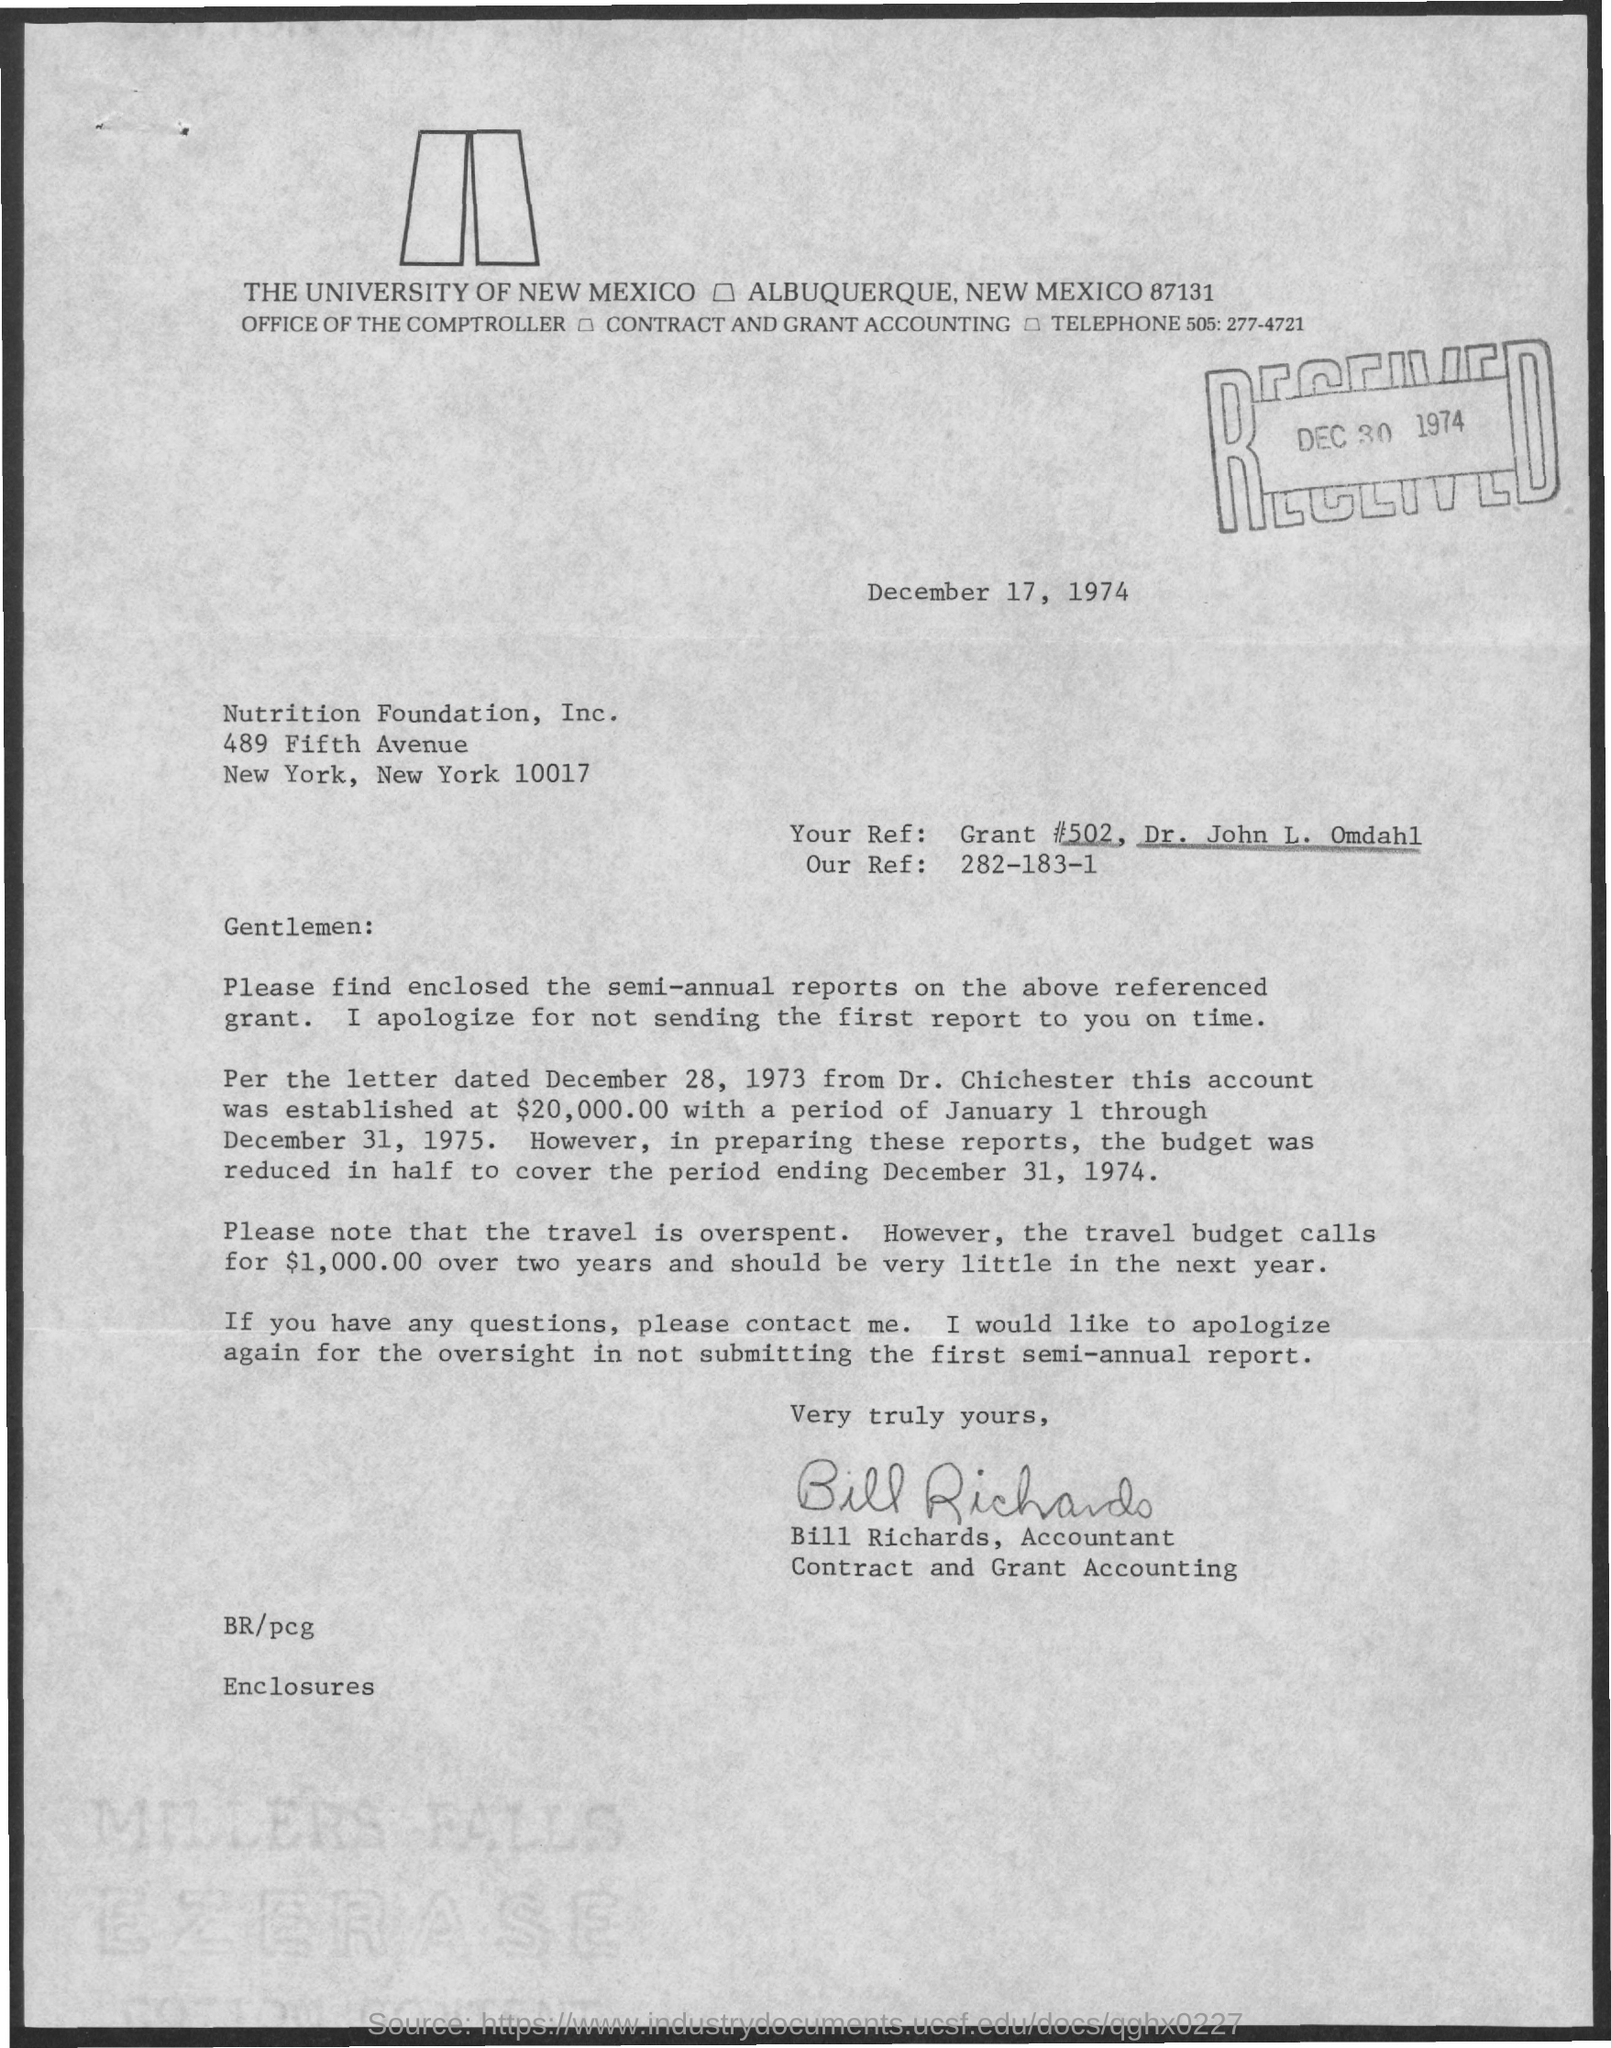What is the date on the document?
Provide a succinct answer. December 17, 1974. What is "Your Ref:"?
Your answer should be very brief. Grant #502, Dr. John L. Omdahl. What is "Our Ref:"?
Your response must be concise. 282-183-1. Who is this letter from?
Ensure brevity in your answer.  Bill Richards. 